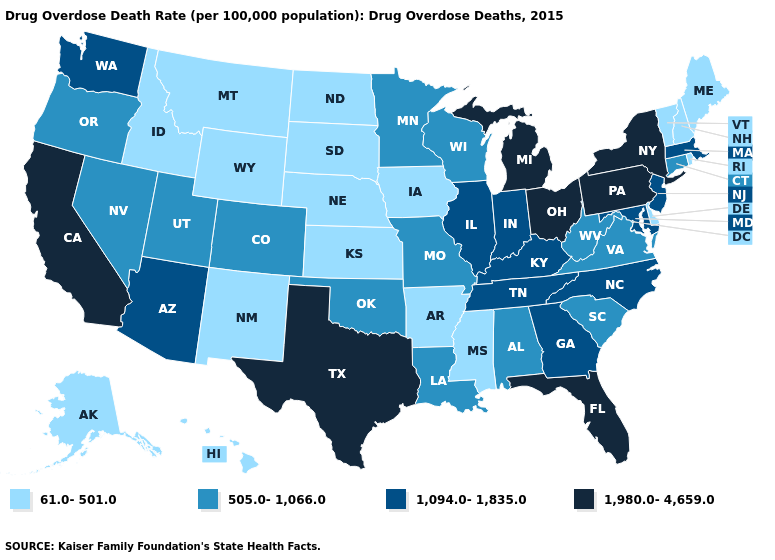Does Indiana have the lowest value in the USA?
Keep it brief. No. Does Tennessee have the lowest value in the USA?
Be succinct. No. How many symbols are there in the legend?
Keep it brief. 4. What is the value of New Mexico?
Answer briefly. 61.0-501.0. What is the value of Georgia?
Short answer required. 1,094.0-1,835.0. Does Kentucky have the highest value in the USA?
Concise answer only. No. Is the legend a continuous bar?
Keep it brief. No. Among the states that border Alabama , does Tennessee have the highest value?
Quick response, please. No. Does Michigan have the highest value in the MidWest?
Give a very brief answer. Yes. What is the value of Maine?
Be succinct. 61.0-501.0. Name the states that have a value in the range 1,094.0-1,835.0?
Short answer required. Arizona, Georgia, Illinois, Indiana, Kentucky, Maryland, Massachusetts, New Jersey, North Carolina, Tennessee, Washington. What is the lowest value in the USA?
Be succinct. 61.0-501.0. What is the highest value in states that border Alabama?
Write a very short answer. 1,980.0-4,659.0. What is the lowest value in the Northeast?
Be succinct. 61.0-501.0. Which states have the highest value in the USA?
Give a very brief answer. California, Florida, Michigan, New York, Ohio, Pennsylvania, Texas. 